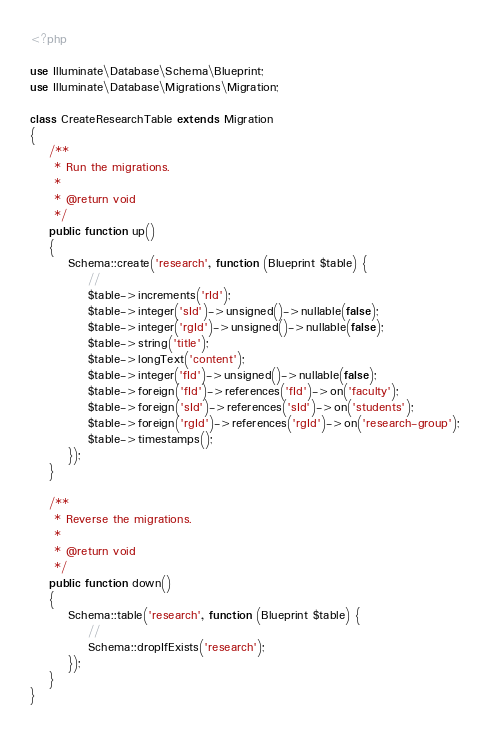<code> <loc_0><loc_0><loc_500><loc_500><_PHP_>
<?php

use Illuminate\Database\Schema\Blueprint;
use Illuminate\Database\Migrations\Migration;

class CreateResearchTable extends Migration
{
    /**
     * Run the migrations.
     *
     * @return void
     */
    public function up()
    {
        Schema::create('research', function (Blueprint $table) {
            //
            $table->increments('rId');
            $table->integer('sId')->unsigned()->nullable(false);
            $table->integer('rgId')->unsigned()->nullable(false);
            $table->string('title');
            $table->longText('content');
            $table->integer('fId')->unsigned()->nullable(false);
            $table->foreign('fId')->references('fId')->on('faculty');
            $table->foreign('sId')->references('sId')->on('students');
            $table->foreign('rgId')->references('rgId')->on('research-group');
            $table->timestamps();
        });
    }

    /**
     * Reverse the migrations.
     *
     * @return void
     */
    public function down()
    {
        Schema::table('research', function (Blueprint $table) {
            //
            Schema::dropIfExists('research');
        });
    }
}
</code> 